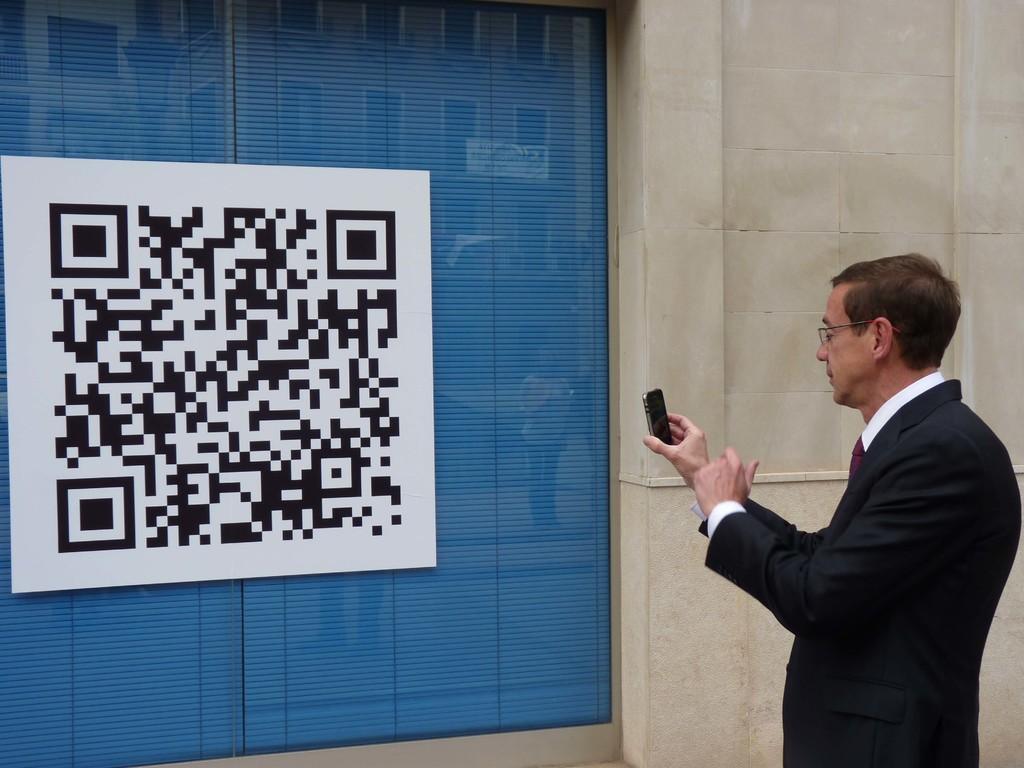How would you summarize this image in a sentence or two? In this image we can see a person standing and holding a mobile phone, also we can see a poster and the wall. 